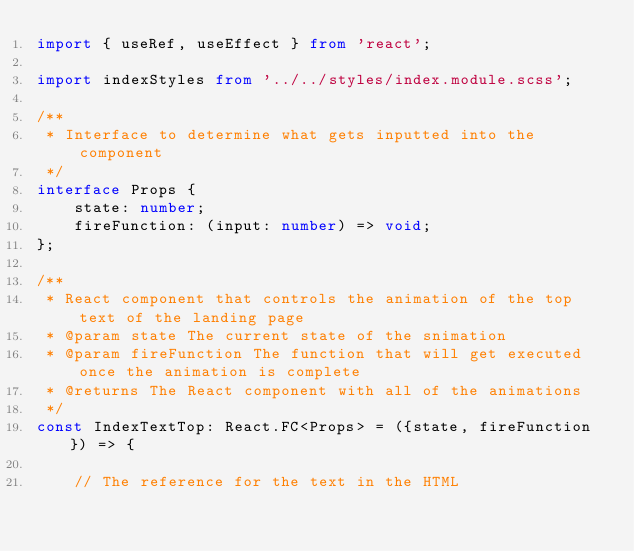Convert code to text. <code><loc_0><loc_0><loc_500><loc_500><_TypeScript_>import { useRef, useEffect } from 'react';

import indexStyles from '../../styles/index.module.scss';

/**
 * Interface to determine what gets inputted into the component
 */
interface Props {
    state: number;
    fireFunction: (input: number) => void;
};

/**
 * React component that controls the animation of the top text of the landing page
 * @param state The current state of the snimation
 * @param fireFunction The function that will get executed once the animation is complete
 * @returns The React component with all of the animations
 */
const IndexTextTop: React.FC<Props> = ({state, fireFunction}) => {

    // The reference for the text in the HTML</code> 